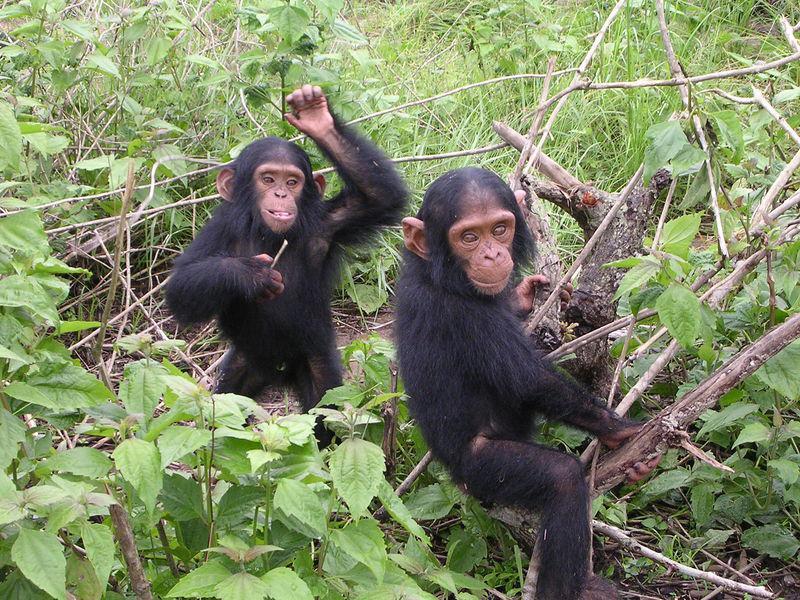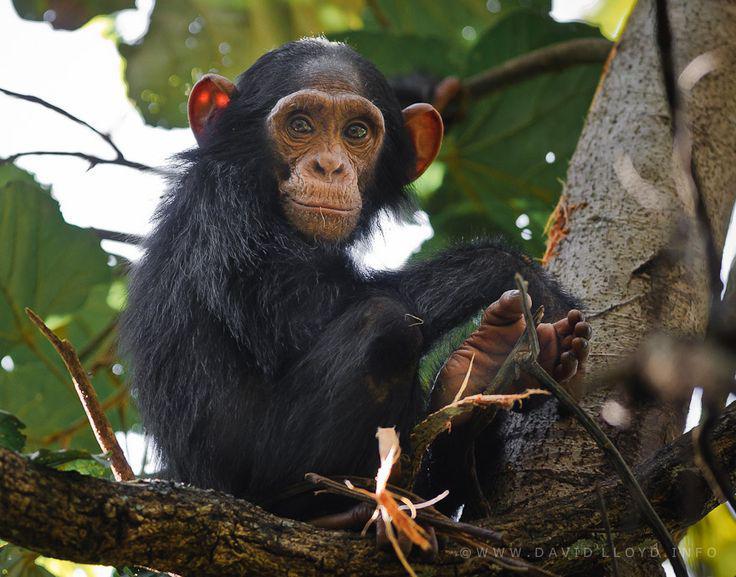The first image is the image on the left, the second image is the image on the right. For the images displayed, is the sentence "The left image contains exactly two chimpanzees." factually correct? Answer yes or no. Yes. The first image is the image on the left, the second image is the image on the right. Evaluate the accuracy of this statement regarding the images: "There are three or fewer apes in total.". Is it true? Answer yes or no. Yes. 